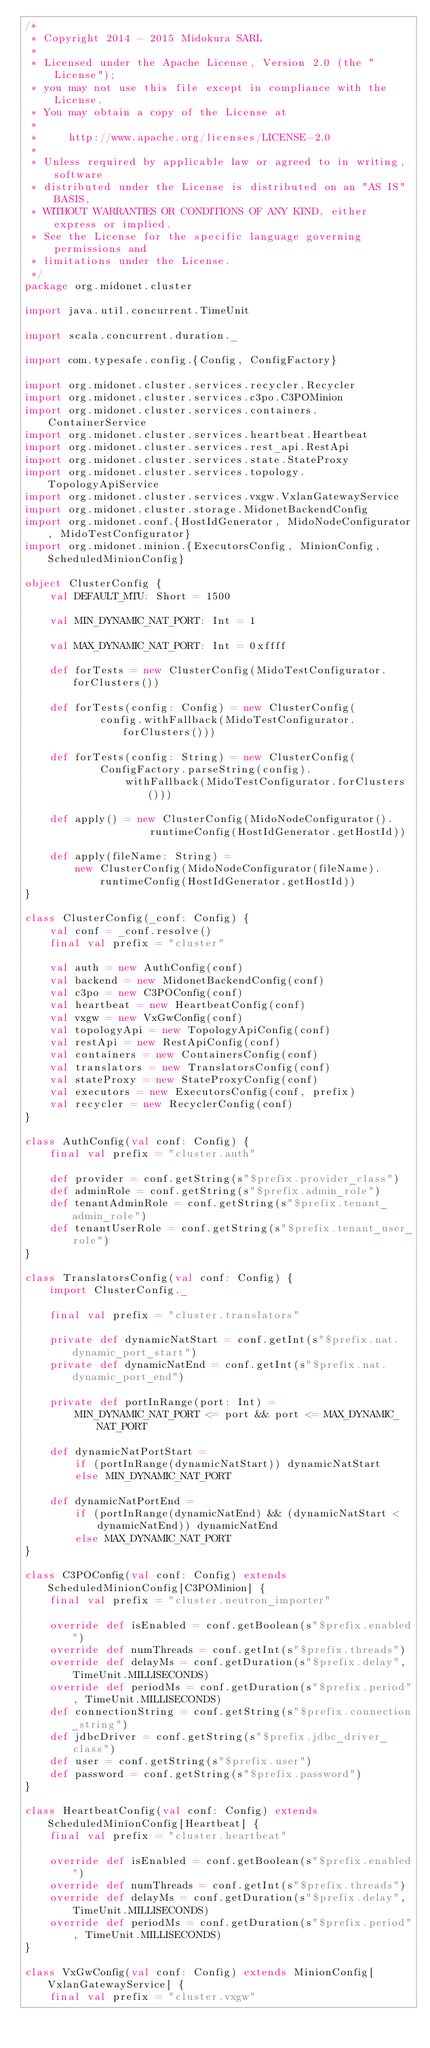<code> <loc_0><loc_0><loc_500><loc_500><_Scala_>/*
 * Copyright 2014 - 2015 Midokura SARL
 *
 * Licensed under the Apache License, Version 2.0 (the "License");
 * you may not use this file except in compliance with the License.
 * You may obtain a copy of the License at
 *
 *     http://www.apache.org/licenses/LICENSE-2.0
 *
 * Unless required by applicable law or agreed to in writing, software
 * distributed under the License is distributed on an "AS IS" BASIS,
 * WITHOUT WARRANTIES OR CONDITIONS OF ANY KIND, either express or implied.
 * See the License for the specific language governing permissions and
 * limitations under the License.
 */
package org.midonet.cluster

import java.util.concurrent.TimeUnit

import scala.concurrent.duration._

import com.typesafe.config.{Config, ConfigFactory}

import org.midonet.cluster.services.recycler.Recycler
import org.midonet.cluster.services.c3po.C3POMinion
import org.midonet.cluster.services.containers.ContainerService
import org.midonet.cluster.services.heartbeat.Heartbeat
import org.midonet.cluster.services.rest_api.RestApi
import org.midonet.cluster.services.state.StateProxy
import org.midonet.cluster.services.topology.TopologyApiService
import org.midonet.cluster.services.vxgw.VxlanGatewayService
import org.midonet.cluster.storage.MidonetBackendConfig
import org.midonet.conf.{HostIdGenerator, MidoNodeConfigurator, MidoTestConfigurator}
import org.midonet.minion.{ExecutorsConfig, MinionConfig, ScheduledMinionConfig}

object ClusterConfig {
    val DEFAULT_MTU: Short = 1500

    val MIN_DYNAMIC_NAT_PORT: Int = 1

    val MAX_DYNAMIC_NAT_PORT: Int = 0xffff

    def forTests = new ClusterConfig(MidoTestConfigurator.forClusters())

    def forTests(config: Config) = new ClusterConfig(
            config.withFallback(MidoTestConfigurator.forClusters()))

    def forTests(config: String) = new ClusterConfig(
            ConfigFactory.parseString(config).
                withFallback(MidoTestConfigurator.forClusters()))

    def apply() = new ClusterConfig(MidoNodeConfigurator().
                    runtimeConfig(HostIdGenerator.getHostId))

    def apply(fileName: String) =
        new ClusterConfig(MidoNodeConfigurator(fileName).
            runtimeConfig(HostIdGenerator.getHostId))
}

class ClusterConfig(_conf: Config) {
    val conf = _conf.resolve()
    final val prefix = "cluster"

    val auth = new AuthConfig(conf)
    val backend = new MidonetBackendConfig(conf)
    val c3po = new C3POConfig(conf)
    val heartbeat = new HeartbeatConfig(conf)
    val vxgw = new VxGwConfig(conf)
    val topologyApi = new TopologyApiConfig(conf)
    val restApi = new RestApiConfig(conf)
    val containers = new ContainersConfig(conf)
    val translators = new TranslatorsConfig(conf)
    val stateProxy = new StateProxyConfig(conf)
    val executors = new ExecutorsConfig(conf, prefix)
    val recycler = new RecyclerConfig(conf)
}

class AuthConfig(val conf: Config) {
    final val prefix = "cluster.auth"

    def provider = conf.getString(s"$prefix.provider_class")
    def adminRole = conf.getString(s"$prefix.admin_role")
    def tenantAdminRole = conf.getString(s"$prefix.tenant_admin_role")
    def tenantUserRole = conf.getString(s"$prefix.tenant_user_role")
}

class TranslatorsConfig(val conf: Config) {
    import ClusterConfig._

    final val prefix = "cluster.translators"

    private def dynamicNatStart = conf.getInt(s"$prefix.nat.dynamic_port_start")
    private def dynamicNatEnd = conf.getInt(s"$prefix.nat.dynamic_port_end")

    private def portInRange(port: Int) =
        MIN_DYNAMIC_NAT_PORT <= port && port <= MAX_DYNAMIC_NAT_PORT

    def dynamicNatPortStart =
        if (portInRange(dynamicNatStart)) dynamicNatStart
        else MIN_DYNAMIC_NAT_PORT

    def dynamicNatPortEnd =
        if (portInRange(dynamicNatEnd) && (dynamicNatStart < dynamicNatEnd)) dynamicNatEnd
        else MAX_DYNAMIC_NAT_PORT
}

class C3POConfig(val conf: Config) extends ScheduledMinionConfig[C3POMinion] {
    final val prefix = "cluster.neutron_importer"

    override def isEnabled = conf.getBoolean(s"$prefix.enabled")
    override def numThreads = conf.getInt(s"$prefix.threads")
    override def delayMs = conf.getDuration(s"$prefix.delay", TimeUnit.MILLISECONDS)
    override def periodMs = conf.getDuration(s"$prefix.period", TimeUnit.MILLISECONDS)
    def connectionString = conf.getString(s"$prefix.connection_string")
    def jdbcDriver = conf.getString(s"$prefix.jdbc_driver_class")
    def user = conf.getString(s"$prefix.user")
    def password = conf.getString(s"$prefix.password")
}

class HeartbeatConfig(val conf: Config) extends ScheduledMinionConfig[Heartbeat] {
    final val prefix = "cluster.heartbeat"

    override def isEnabled = conf.getBoolean(s"$prefix.enabled")
    override def numThreads = conf.getInt(s"$prefix.threads")
    override def delayMs = conf.getDuration(s"$prefix.delay", TimeUnit.MILLISECONDS)
    override def periodMs = conf.getDuration(s"$prefix.period", TimeUnit.MILLISECONDS)
}

class VxGwConfig(val conf: Config) extends MinionConfig[VxlanGatewayService] {
    final val prefix = "cluster.vxgw"
</code> 